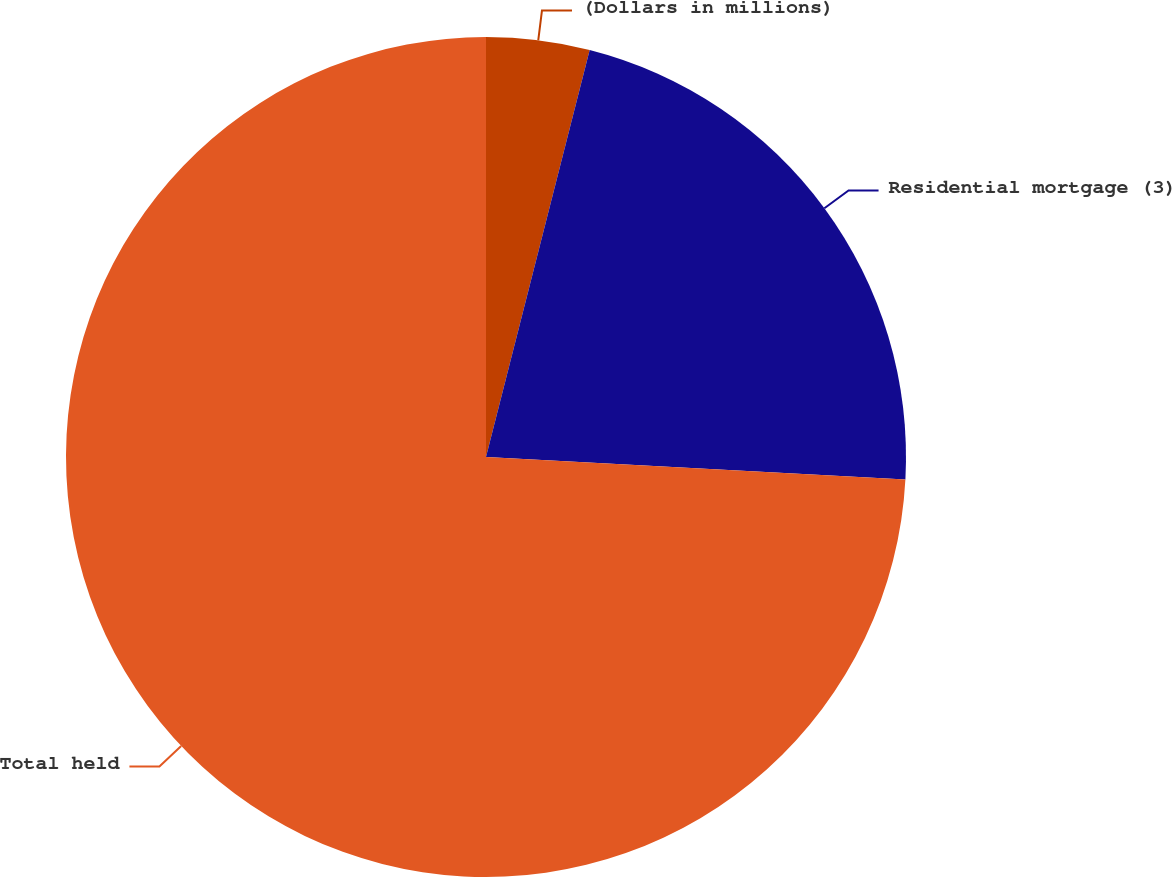Convert chart to OTSL. <chart><loc_0><loc_0><loc_500><loc_500><pie_chart><fcel>(Dollars in millions)<fcel>Residential mortgage (3)<fcel>Total held<nl><fcel>3.97%<fcel>21.88%<fcel>74.15%<nl></chart> 